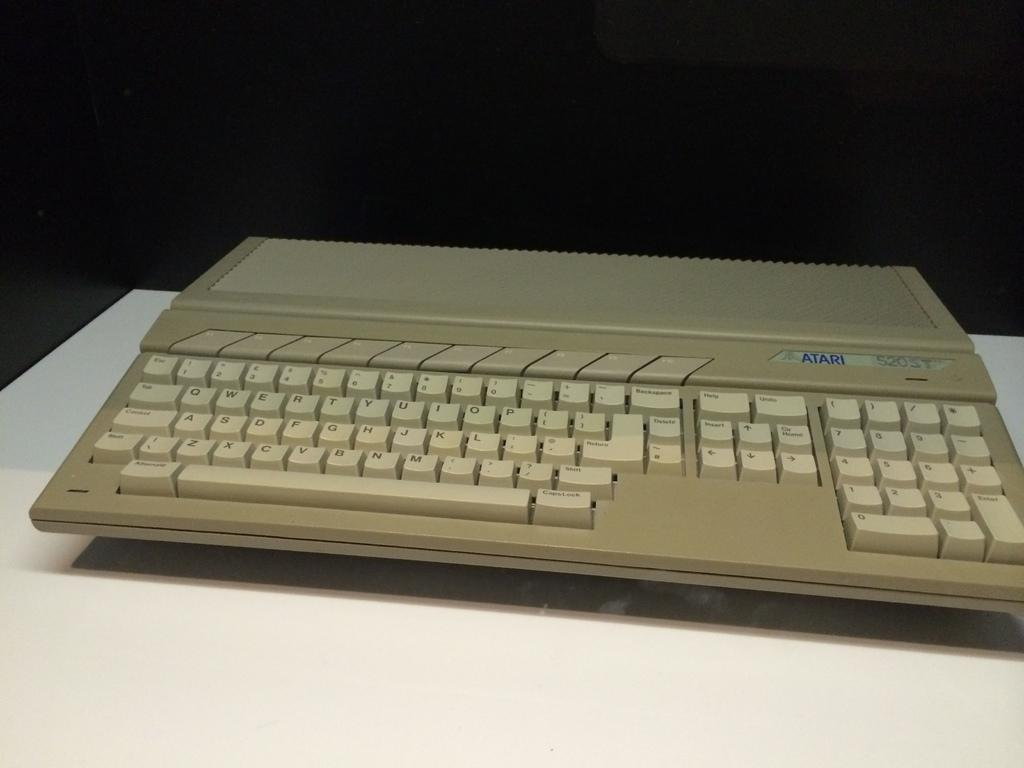What object is the main focus of the image? There is a keyboard in the image. Where is the keyboard located? The keyboard is placed on a table. What type of punishment is being administered to the keyboard in the image? There is no punishment being administered to the keyboard in the image; it is simply placed on a table. What number is associated with the keyboard in the image? There is no specific number associated with the keyboard in the image. 